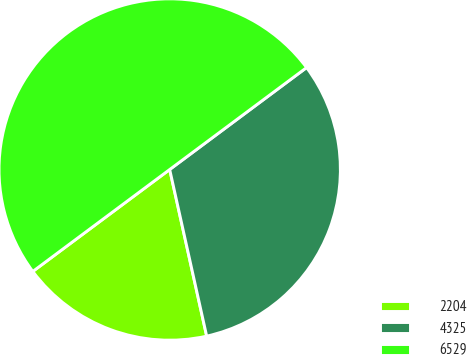Convert chart to OTSL. <chart><loc_0><loc_0><loc_500><loc_500><pie_chart><fcel>2204<fcel>4325<fcel>6529<nl><fcel>18.29%<fcel>31.71%<fcel>50.0%<nl></chart> 